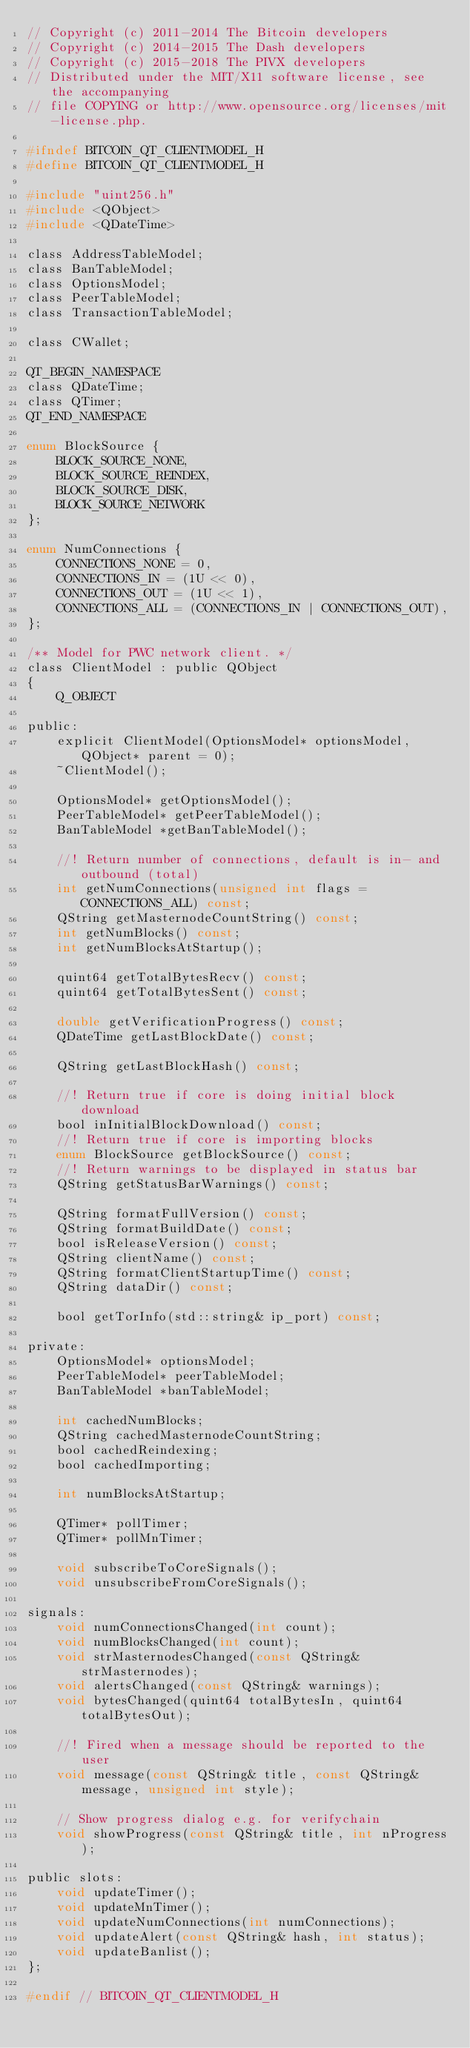Convert code to text. <code><loc_0><loc_0><loc_500><loc_500><_C_>// Copyright (c) 2011-2014 The Bitcoin developers
// Copyright (c) 2014-2015 The Dash developers
// Copyright (c) 2015-2018 The PIVX developers
// Distributed under the MIT/X11 software license, see the accompanying
// file COPYING or http://www.opensource.org/licenses/mit-license.php.

#ifndef BITCOIN_QT_CLIENTMODEL_H
#define BITCOIN_QT_CLIENTMODEL_H

#include "uint256.h"
#include <QObject>
#include <QDateTime>

class AddressTableModel;
class BanTableModel;
class OptionsModel;
class PeerTableModel;
class TransactionTableModel;

class CWallet;

QT_BEGIN_NAMESPACE
class QDateTime;
class QTimer;
QT_END_NAMESPACE

enum BlockSource {
    BLOCK_SOURCE_NONE,
    BLOCK_SOURCE_REINDEX,
    BLOCK_SOURCE_DISK,
    BLOCK_SOURCE_NETWORK
};

enum NumConnections {
    CONNECTIONS_NONE = 0,
    CONNECTIONS_IN = (1U << 0),
    CONNECTIONS_OUT = (1U << 1),
    CONNECTIONS_ALL = (CONNECTIONS_IN | CONNECTIONS_OUT),
};

/** Model for PWC network client. */
class ClientModel : public QObject
{
    Q_OBJECT

public:
    explicit ClientModel(OptionsModel* optionsModel, QObject* parent = 0);
    ~ClientModel();

    OptionsModel* getOptionsModel();
    PeerTableModel* getPeerTableModel();
    BanTableModel *getBanTableModel();

    //! Return number of connections, default is in- and outbound (total)
    int getNumConnections(unsigned int flags = CONNECTIONS_ALL) const;
    QString getMasternodeCountString() const;
    int getNumBlocks() const;
    int getNumBlocksAtStartup();

    quint64 getTotalBytesRecv() const;
    quint64 getTotalBytesSent() const;

    double getVerificationProgress() const;
    QDateTime getLastBlockDate() const;

    QString getLastBlockHash() const;

    //! Return true if core is doing initial block download
    bool inInitialBlockDownload() const;
    //! Return true if core is importing blocks
    enum BlockSource getBlockSource() const;
    //! Return warnings to be displayed in status bar
    QString getStatusBarWarnings() const;

    QString formatFullVersion() const;
    QString formatBuildDate() const;
    bool isReleaseVersion() const;
    QString clientName() const;
    QString formatClientStartupTime() const;
    QString dataDir() const;

    bool getTorInfo(std::string& ip_port) const;

private:
    OptionsModel* optionsModel;
    PeerTableModel* peerTableModel;
    BanTableModel *banTableModel;

    int cachedNumBlocks;
    QString cachedMasternodeCountString;
    bool cachedReindexing;
    bool cachedImporting;

    int numBlocksAtStartup;

    QTimer* pollTimer;
    QTimer* pollMnTimer;

    void subscribeToCoreSignals();
    void unsubscribeFromCoreSignals();

signals:
    void numConnectionsChanged(int count);
    void numBlocksChanged(int count);
    void strMasternodesChanged(const QString& strMasternodes);
    void alertsChanged(const QString& warnings);
    void bytesChanged(quint64 totalBytesIn, quint64 totalBytesOut);

    //! Fired when a message should be reported to the user
    void message(const QString& title, const QString& message, unsigned int style);

    // Show progress dialog e.g. for verifychain
    void showProgress(const QString& title, int nProgress);

public slots:
    void updateTimer();
    void updateMnTimer();
    void updateNumConnections(int numConnections);
    void updateAlert(const QString& hash, int status);
    void updateBanlist();
};

#endif // BITCOIN_QT_CLIENTMODEL_H
</code> 